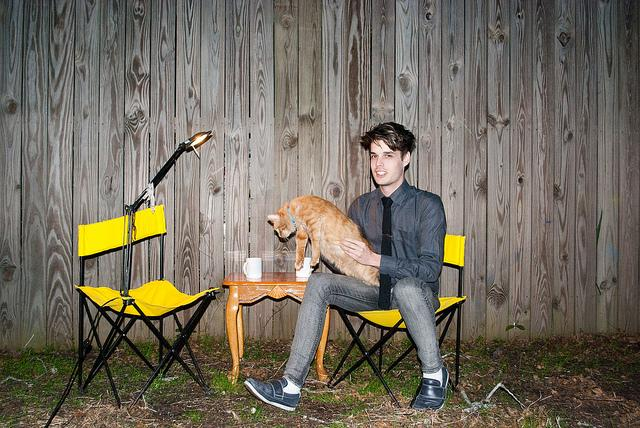What is the breed of this cat? tabby 